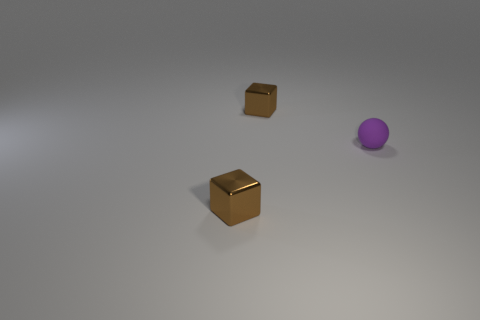Are there any other things that have the same material as the tiny purple ball?
Keep it short and to the point. No. How many other shiny objects have the same size as the purple thing?
Your answer should be very brief. 2. Are there fewer tiny blue metallic blocks than tiny matte objects?
Give a very brief answer. Yes. There is a small brown thing behind the small metal block that is in front of the purple thing; what is its shape?
Offer a very short reply. Cube. Are there any other things of the same shape as the small purple thing?
Keep it short and to the point. No. What is the material of the tiny purple object?
Keep it short and to the point. Rubber. There is a purple rubber ball; are there any shiny blocks behind it?
Your response must be concise. Yes. There is a tiny cube that is behind the small sphere; how many tiny purple balls are behind it?
Offer a very short reply. 0. What number of other objects are the same material as the purple sphere?
Provide a succinct answer. 0. There is a matte ball; what number of purple balls are in front of it?
Ensure brevity in your answer.  0. 